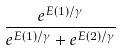<formula> <loc_0><loc_0><loc_500><loc_500>\frac { e ^ { E ( 1 ) / \gamma } } { e ^ { E ( 1 ) / \gamma } + e ^ { E ( 2 ) / \gamma } }</formula> 